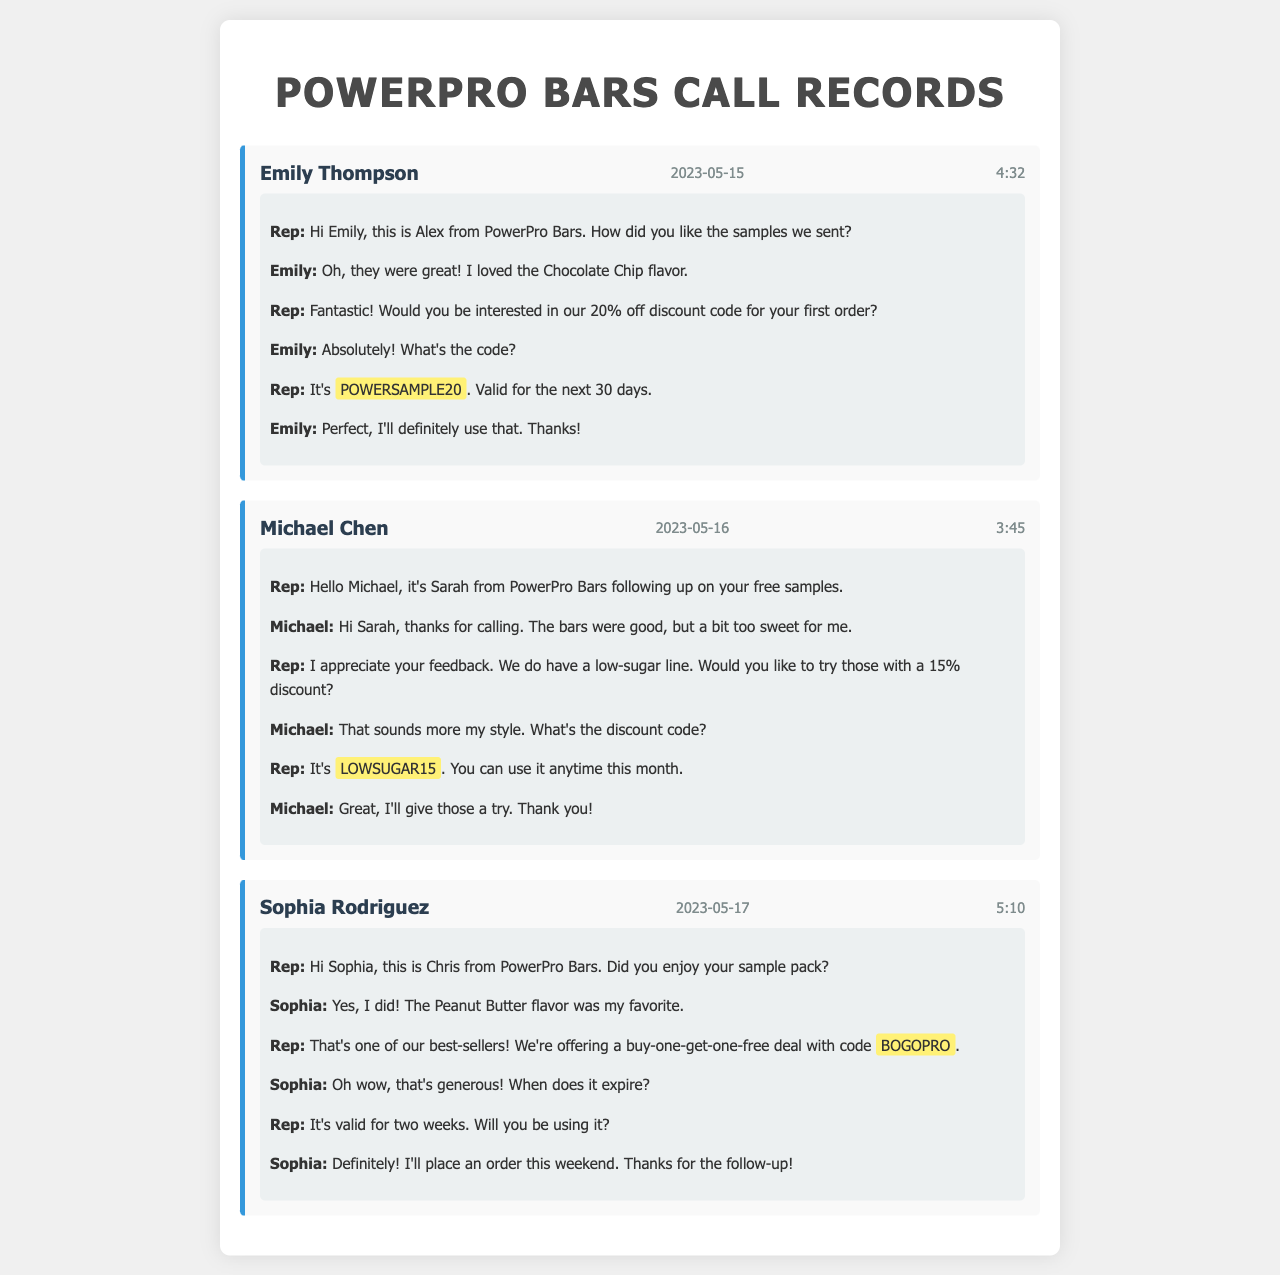What is the name of the first customer? The first customer mentioned in the call records is Emily Thompson.
Answer: Emily Thompson What discount code was provided to Michael Chen? The discount code offered to Michael Chen for his order is mentioned in the call.
Answer: LOWSUGAR15 How long is the discount code POWERSAMPLE20 valid for? The validity period of the code POWERSAMPLE20 is specified in the document.
Answer: 30 days Which flavor did Sophia Rodriguez enjoy the most? The document states that Sophia's favorite flavor from the samples was mentioned during the call.
Answer: Peanut Butter Who is the representative that called Emily Thompson? The call record includes information about the representative reaching out to Emily.
Answer: Alex What special promotion is offered alongside Sophia's discount code? The document mentions a special offer related to the promo code for Sophia.
Answer: buy-one-get-one-free How many minutes was the call with Michael Chen? The length of the call with Michael Chen is documented in the call records.
Answer: 3:45 What feedback did Michael Chen give about the protein bars? Michael's feedback during the call indicates his opinion about the taste of the protein bars.
Answer: a bit too sweet What is the date of the follow-up call with Sophia Rodriguez? The call date for Sophia Rodriguez's follow-up is recorded in the document.
Answer: 2023-05-17 